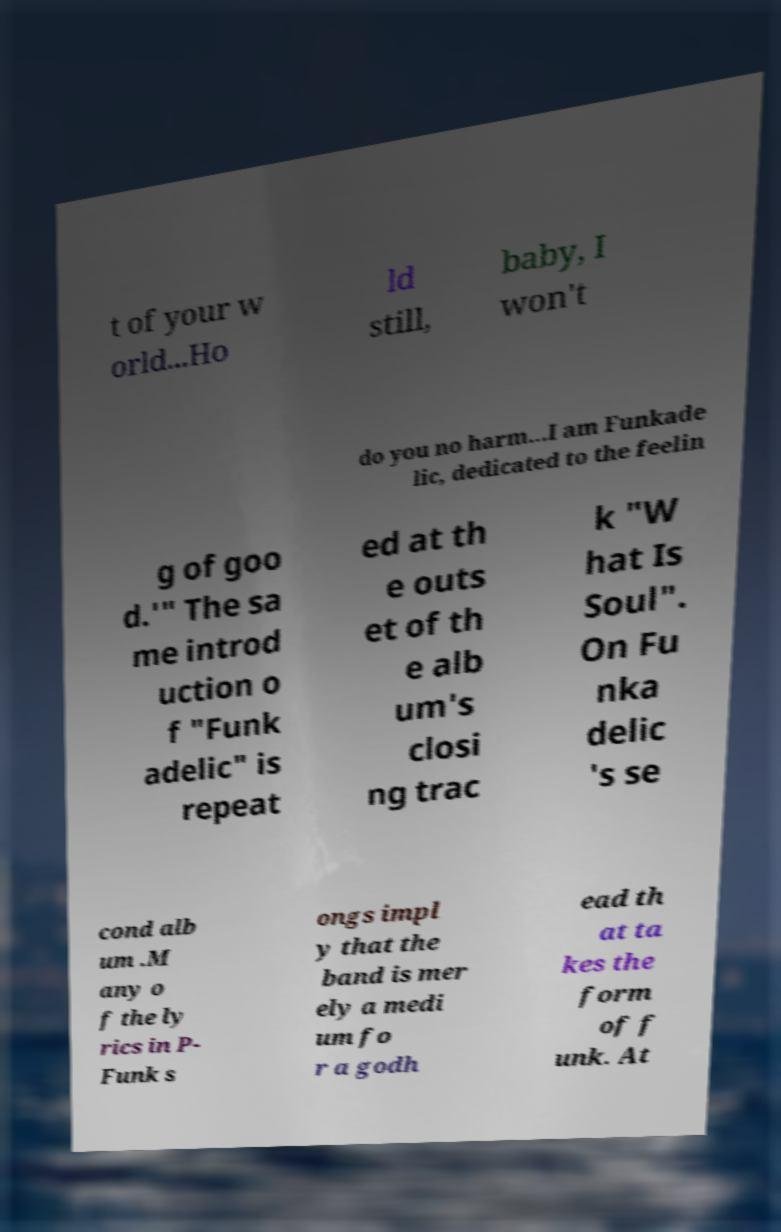Please read and relay the text visible in this image. What does it say? t of your w orld...Ho ld still, baby, I won't do you no harm...I am Funkade lic, dedicated to the feelin g of goo d.'" The sa me introd uction o f "Funk adelic" is repeat ed at th e outs et of th e alb um's closi ng trac k "W hat Is Soul". On Fu nka delic 's se cond alb um .M any o f the ly rics in P- Funk s ongs impl y that the band is mer ely a medi um fo r a godh ead th at ta kes the form of f unk. At 